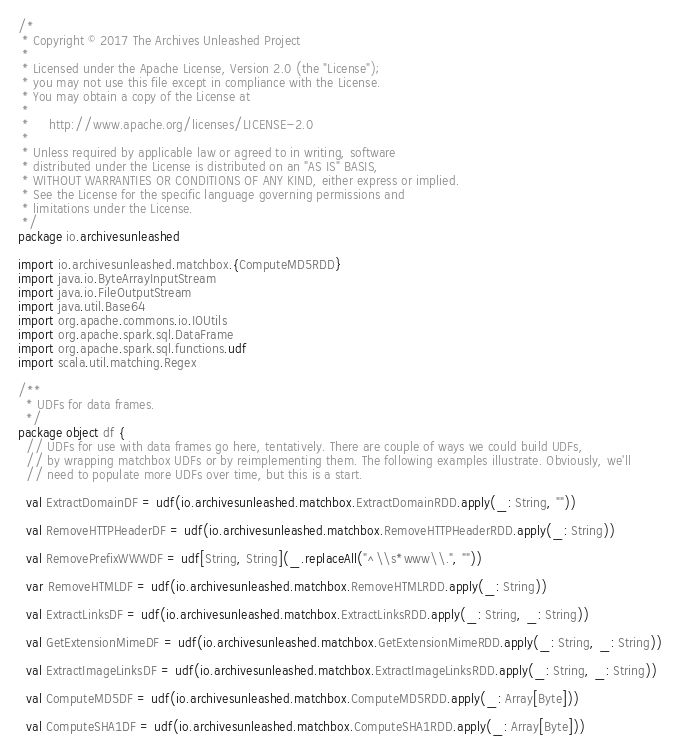Convert code to text. <code><loc_0><loc_0><loc_500><loc_500><_Scala_>/*
 * Copyright © 2017 The Archives Unleashed Project
 *
 * Licensed under the Apache License, Version 2.0 (the "License");
 * you may not use this file except in compliance with the License.
 * You may obtain a copy of the License at
 *
 *     http://www.apache.org/licenses/LICENSE-2.0
 *
 * Unless required by applicable law or agreed to in writing, software
 * distributed under the License is distributed on an "AS IS" BASIS,
 * WITHOUT WARRANTIES OR CONDITIONS OF ANY KIND, either express or implied.
 * See the License for the specific language governing permissions and
 * limitations under the License.
 */
package io.archivesunleashed

import io.archivesunleashed.matchbox.{ComputeMD5RDD}
import java.io.ByteArrayInputStream
import java.io.FileOutputStream
import java.util.Base64
import org.apache.commons.io.IOUtils
import org.apache.spark.sql.DataFrame
import org.apache.spark.sql.functions.udf
import scala.util.matching.Regex

/**
  * UDFs for data frames.
  */
package object df {
  // UDFs for use with data frames go here, tentatively. There are couple of ways we could build UDFs,
  // by wrapping matchbox UDFs or by reimplementing them. The following examples illustrate. Obviously, we'll
  // need to populate more UDFs over time, but this is a start.

  val ExtractDomainDF = udf(io.archivesunleashed.matchbox.ExtractDomainRDD.apply(_: String, ""))

  val RemoveHTTPHeaderDF = udf(io.archivesunleashed.matchbox.RemoveHTTPHeaderRDD.apply(_: String))

  val RemovePrefixWWWDF = udf[String, String](_.replaceAll("^\\s*www\\.", ""))

  var RemoveHTMLDF = udf(io.archivesunleashed.matchbox.RemoveHTMLRDD.apply(_: String))

  val ExtractLinksDF = udf(io.archivesunleashed.matchbox.ExtractLinksRDD.apply(_: String, _: String))

  val GetExtensionMimeDF = udf(io.archivesunleashed.matchbox.GetExtensionMimeRDD.apply(_: String, _: String))

  val ExtractImageLinksDF = udf(io.archivesunleashed.matchbox.ExtractImageLinksRDD.apply(_: String, _: String))

  val ComputeMD5DF = udf(io.archivesunleashed.matchbox.ComputeMD5RDD.apply(_: Array[Byte]))

  val ComputeSHA1DF = udf(io.archivesunleashed.matchbox.ComputeSHA1RDD.apply(_: Array[Byte]))
</code> 